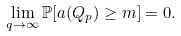Convert formula to latex. <formula><loc_0><loc_0><loc_500><loc_500>\lim _ { q \rightarrow \infty } \mathbb { P } [ a ( Q _ { p } ) \geq m ] = 0 .</formula> 